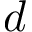Convert formula to latex. <formula><loc_0><loc_0><loc_500><loc_500>d</formula> 